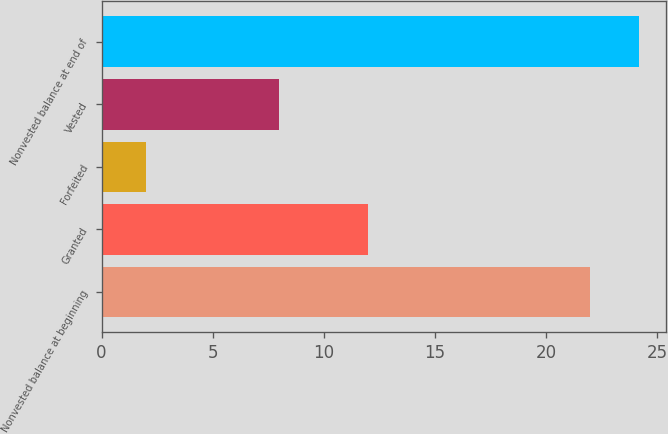<chart> <loc_0><loc_0><loc_500><loc_500><bar_chart><fcel>Nonvested balance at beginning<fcel>Granted<fcel>Forfeited<fcel>Vested<fcel>Nonvested balance at end of<nl><fcel>22<fcel>12<fcel>2<fcel>8<fcel>24.2<nl></chart> 